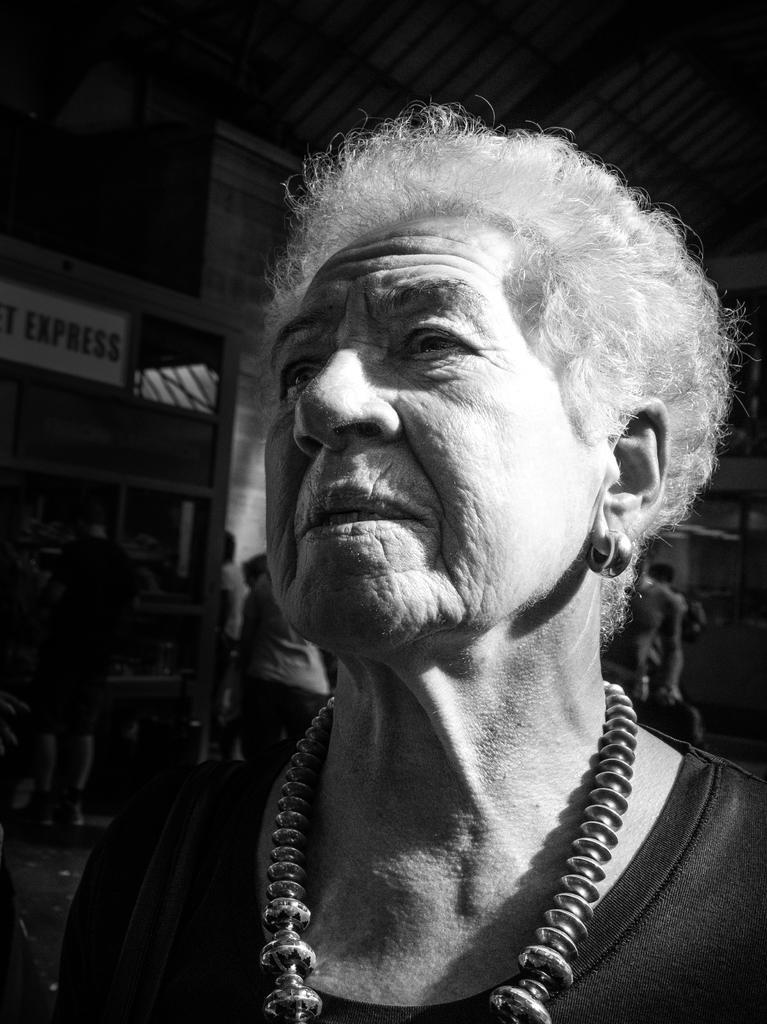How would you summarize this image in a sentence or two? In this image we can see a person. Behind the person we can see a group of persons and a wall. At the top we can see the roof. 